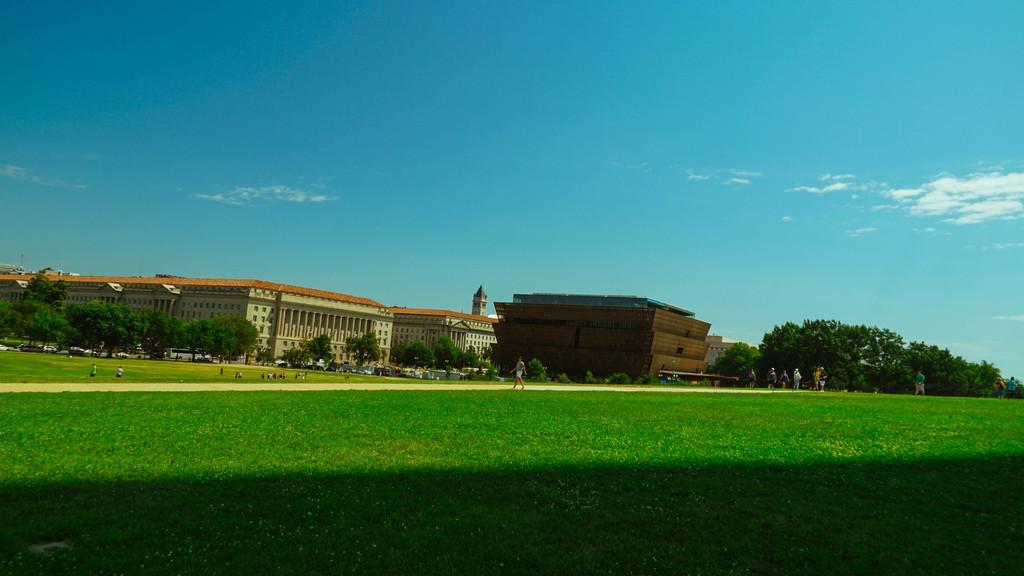Could you give a brief overview of what you see in this image? There is a grassy land at the bottom of this image. We can see people, trees and buildings in the middle of this image and the sky in the background. 